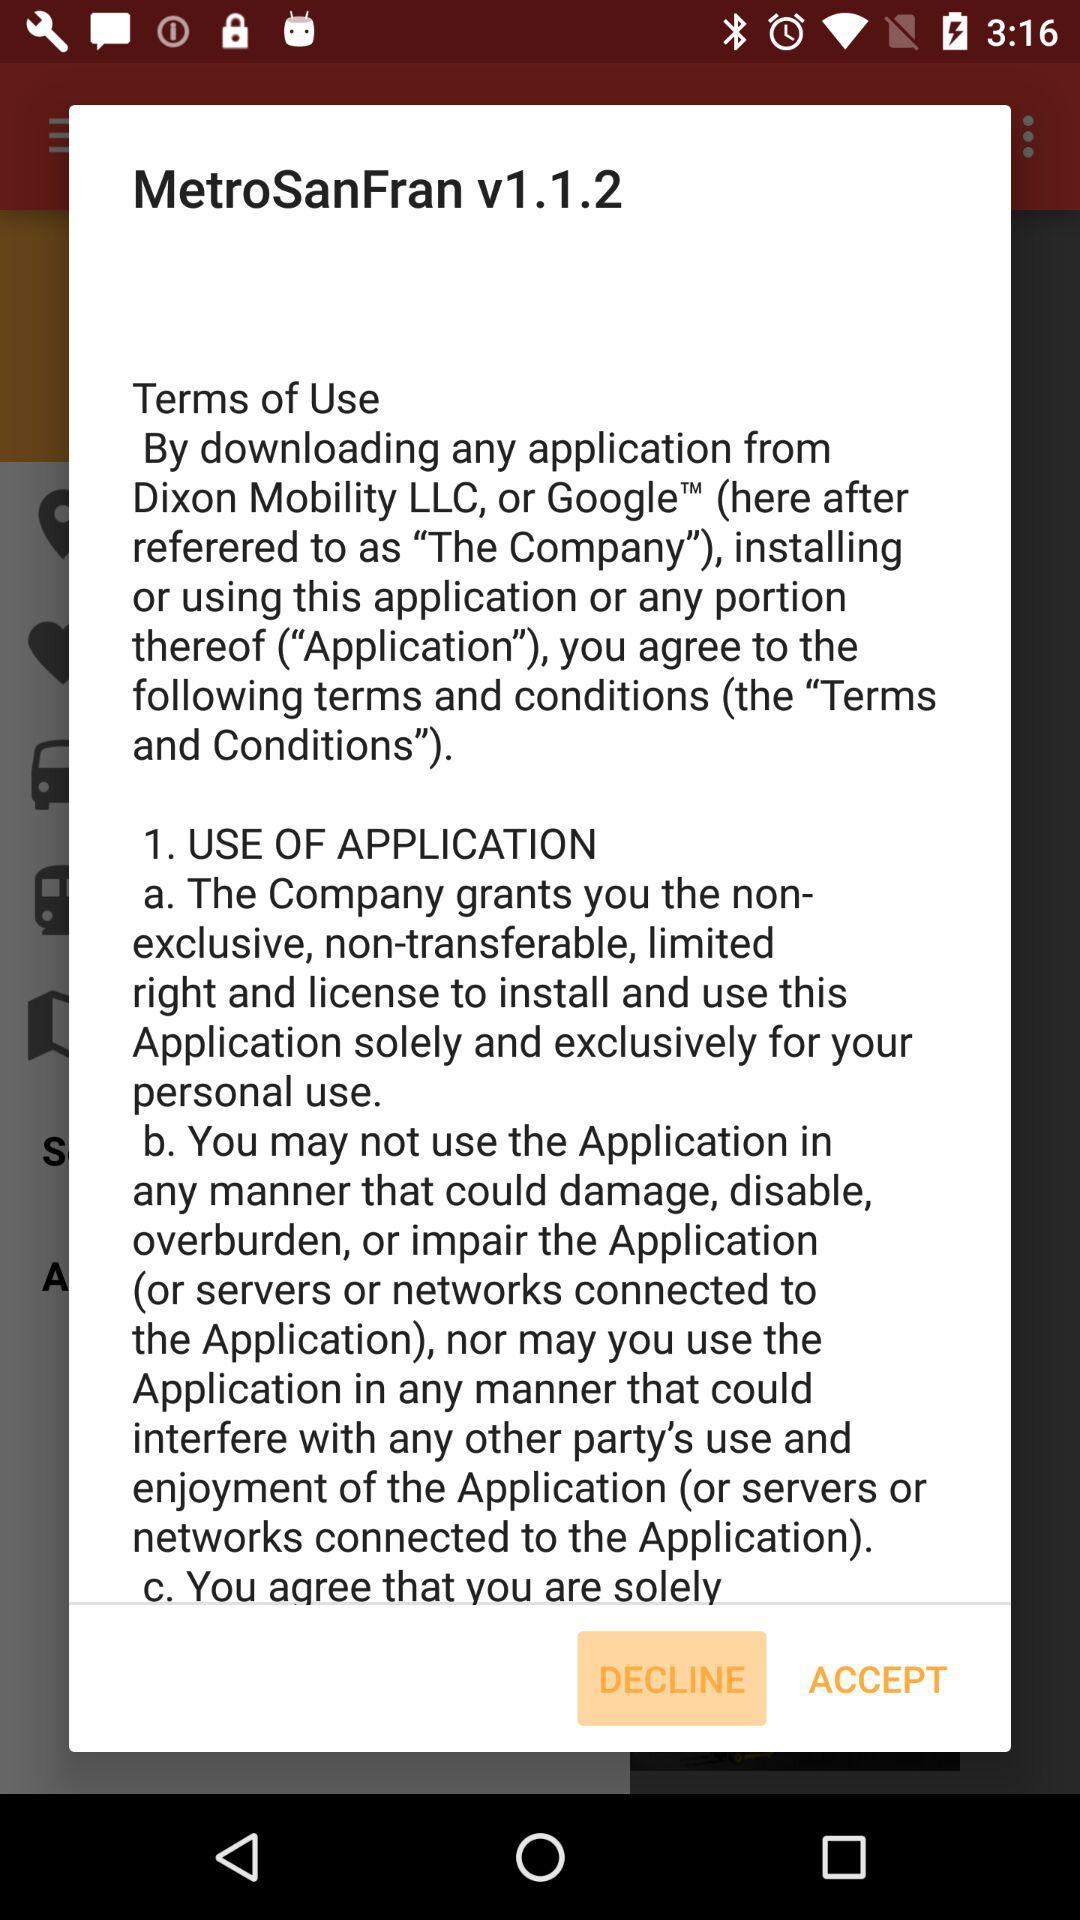Where is the nearest metro stop?
When the provided information is insufficient, respond with <no answer>. <no answer> 